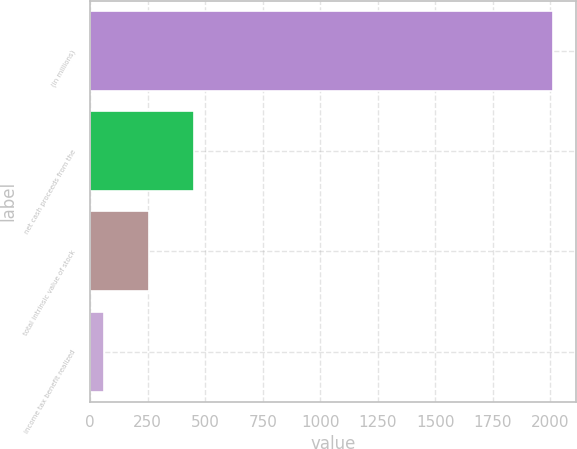Convert chart to OTSL. <chart><loc_0><loc_0><loc_500><loc_500><bar_chart><fcel>(in millions)<fcel>net cash proceeds from the<fcel>total intrinsic value of stock<fcel>income tax benefit realized<nl><fcel>2013<fcel>451.4<fcel>256.2<fcel>61<nl></chart> 